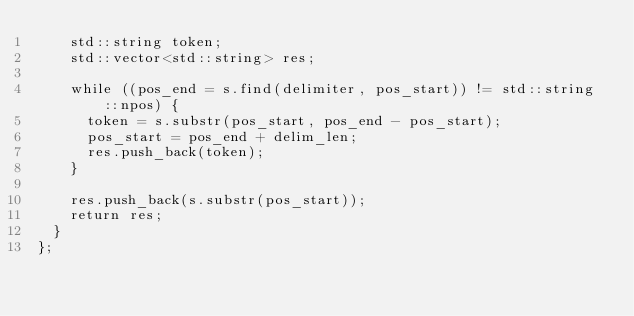<code> <loc_0><loc_0><loc_500><loc_500><_C_>    std::string token;
    std::vector<std::string> res;

    while ((pos_end = s.find(delimiter, pos_start)) != std::string::npos) {
      token = s.substr(pos_start, pos_end - pos_start);
      pos_start = pos_end + delim_len;
      res.push_back(token);
    }

    res.push_back(s.substr(pos_start));
    return res;
  }
};
</code> 